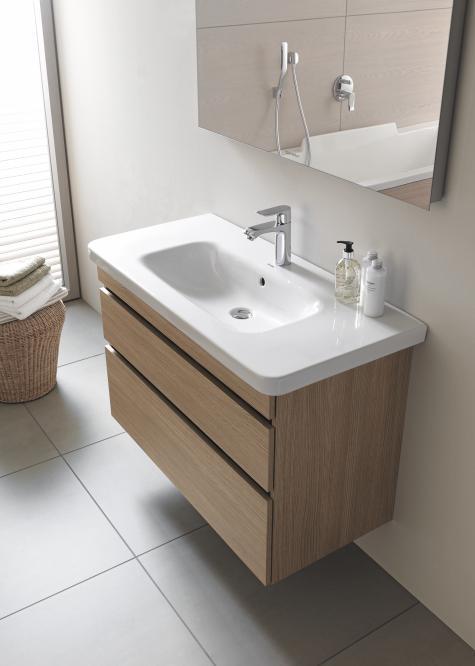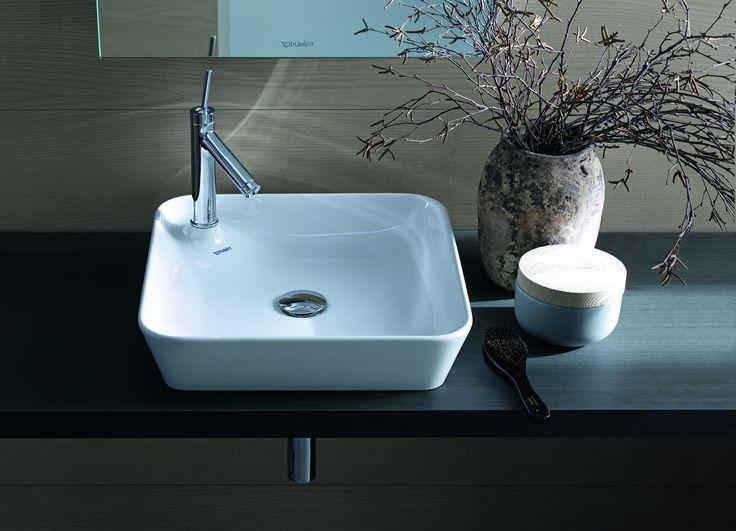The first image is the image on the left, the second image is the image on the right. Considering the images on both sides, is "There is a mirror positioned above every sink basin." valid? Answer yes or no. Yes. The first image is the image on the left, the second image is the image on the right. Evaluate the accuracy of this statement regarding the images: "The left image features at least one round sink inset in white and mounted on the wall, and the right image features a rectangular white sink.". Is it true? Answer yes or no. No. 